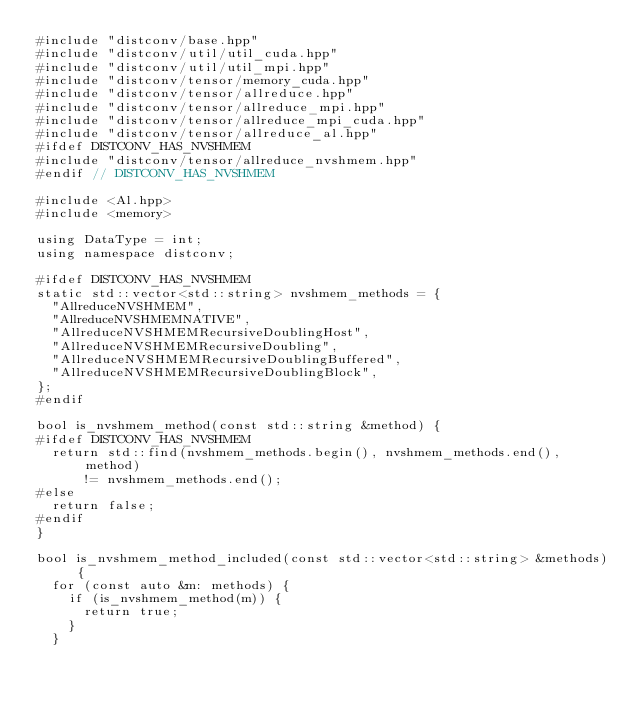<code> <loc_0><loc_0><loc_500><loc_500><_Cuda_>#include "distconv/base.hpp"
#include "distconv/util/util_cuda.hpp"
#include "distconv/util/util_mpi.hpp"
#include "distconv/tensor/memory_cuda.hpp"
#include "distconv/tensor/allreduce.hpp"
#include "distconv/tensor/allreduce_mpi.hpp"
#include "distconv/tensor/allreduce_mpi_cuda.hpp"
#include "distconv/tensor/allreduce_al.hpp"
#ifdef DISTCONV_HAS_NVSHMEM
#include "distconv/tensor/allreduce_nvshmem.hpp"
#endif // DISTCONV_HAS_NVSHMEM

#include <Al.hpp>
#include <memory>

using DataType = int;
using namespace distconv;

#ifdef DISTCONV_HAS_NVSHMEM
static std::vector<std::string> nvshmem_methods = {
  "AllreduceNVSHMEM",
  "AllreduceNVSHMEMNATIVE",
  "AllreduceNVSHMEMRecursiveDoublingHost",
  "AllreduceNVSHMEMRecursiveDoubling",
  "AllreduceNVSHMEMRecursiveDoublingBuffered",
  "AllreduceNVSHMEMRecursiveDoublingBlock",
};
#endif

bool is_nvshmem_method(const std::string &method) {
#ifdef DISTCONV_HAS_NVSHMEM
  return std::find(nvshmem_methods.begin(), nvshmem_methods.end(), method)
      != nvshmem_methods.end();
#else
  return false;
#endif
}

bool is_nvshmem_method_included(const std::vector<std::string> &methods) {
  for (const auto &m: methods) {
    if (is_nvshmem_method(m)) {
      return true;
    }
  }</code> 